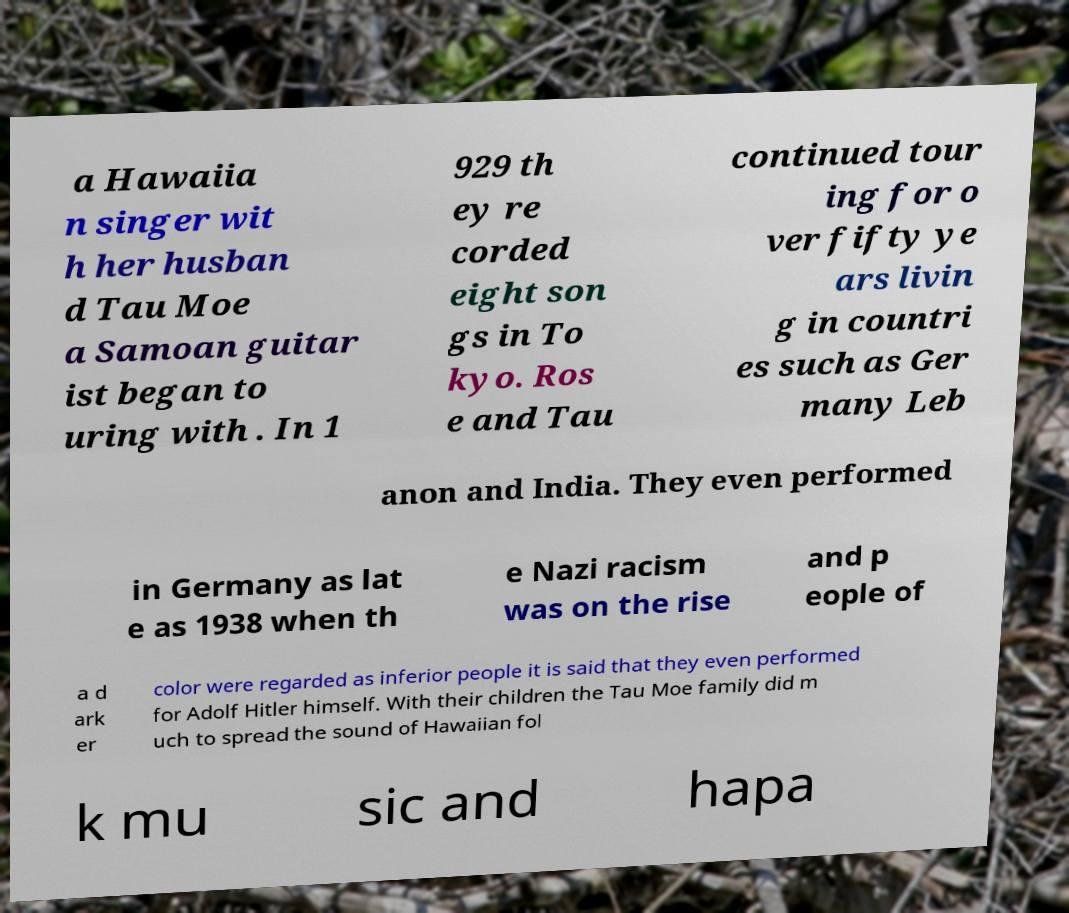Please identify and transcribe the text found in this image. a Hawaiia n singer wit h her husban d Tau Moe a Samoan guitar ist began to uring with . In 1 929 th ey re corded eight son gs in To kyo. Ros e and Tau continued tour ing for o ver fifty ye ars livin g in countri es such as Ger many Leb anon and India. They even performed in Germany as lat e as 1938 when th e Nazi racism was on the rise and p eople of a d ark er color were regarded as inferior people it is said that they even performed for Adolf Hitler himself. With their children the Tau Moe family did m uch to spread the sound of Hawaiian fol k mu sic and hapa 